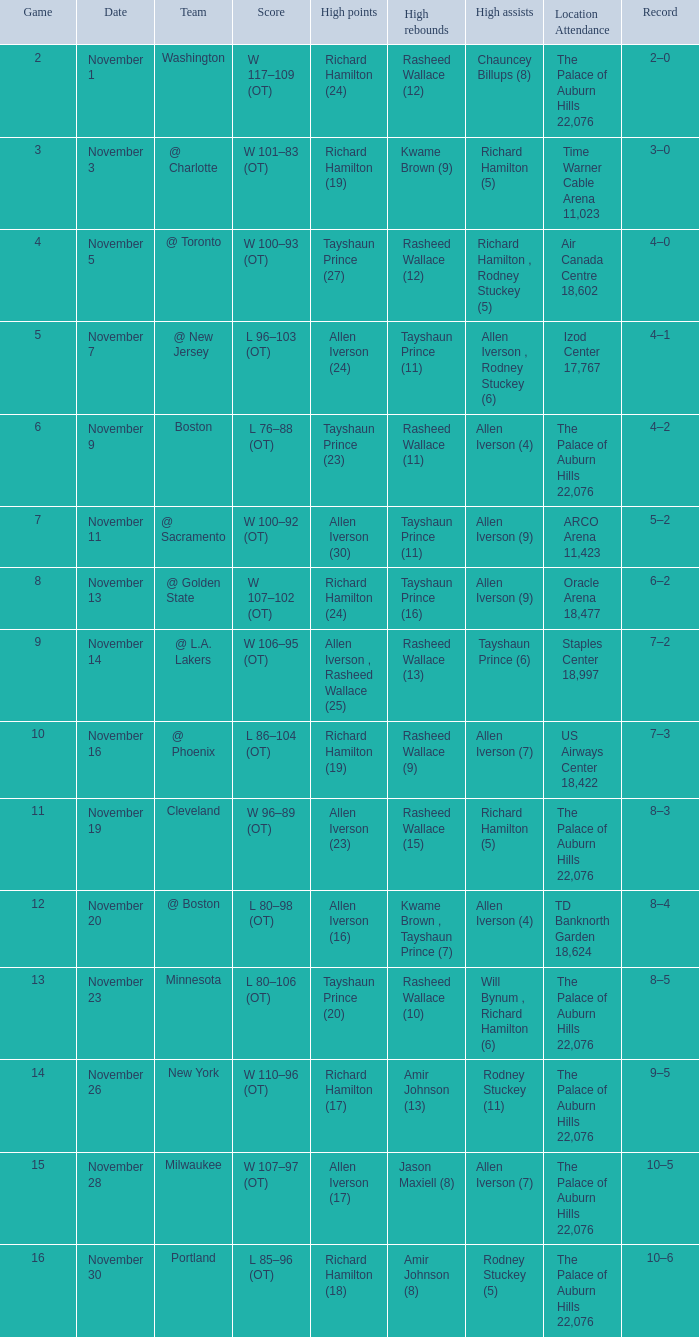When the game score is below 10 and chauncey billups has 8 high assists, what are the high points? Richard Hamilton (24). 